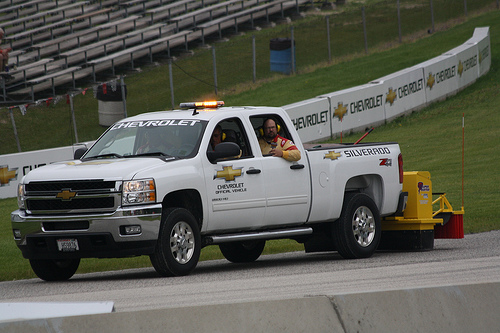<image>
Is the man behind the truck? No. The man is not behind the truck. From this viewpoint, the man appears to be positioned elsewhere in the scene. Is there a man next to the truck? No. The man is not positioned next to the truck. They are located in different areas of the scene. 